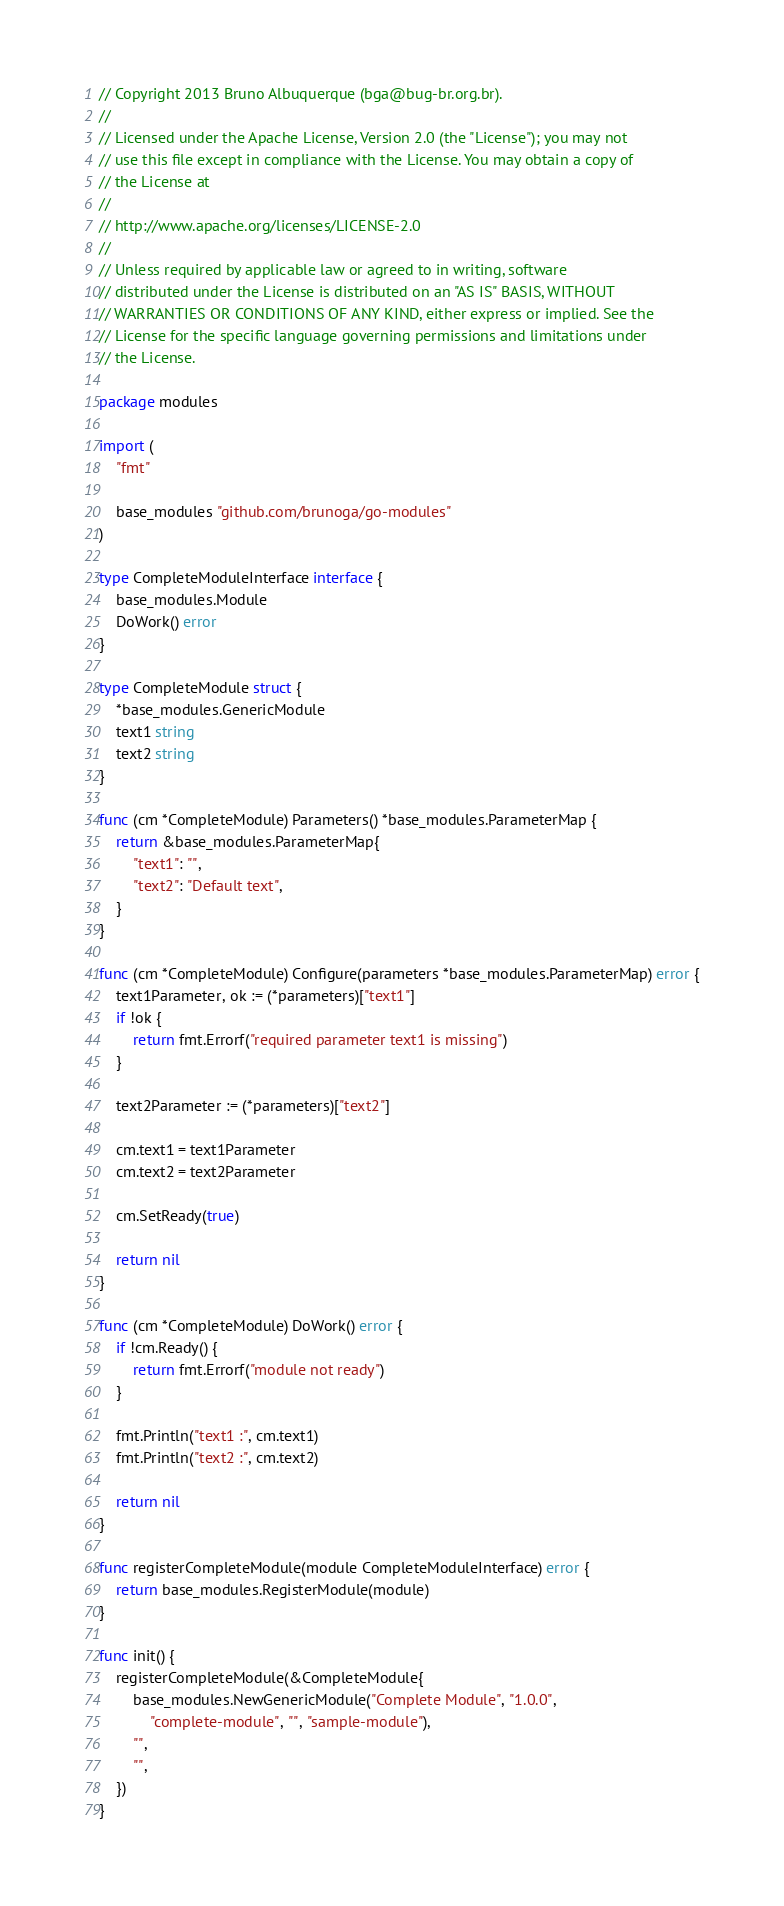<code> <loc_0><loc_0><loc_500><loc_500><_Go_>// Copyright 2013 Bruno Albuquerque (bga@bug-br.org.br).
//
// Licensed under the Apache License, Version 2.0 (the "License"); you may not
// use this file except in compliance with the License. You may obtain a copy of
// the License at
//
// http://www.apache.org/licenses/LICENSE-2.0
//
// Unless required by applicable law or agreed to in writing, software
// distributed under the License is distributed on an "AS IS" BASIS, WITHOUT
// WARRANTIES OR CONDITIONS OF ANY KIND, either express or implied. See the
// License for the specific language governing permissions and limitations under
// the License.

package modules

import (
	"fmt"

	base_modules "github.com/brunoga/go-modules"
)

type CompleteModuleInterface interface {
	base_modules.Module
	DoWork() error
}

type CompleteModule struct {
	*base_modules.GenericModule
	text1 string
	text2 string
}

func (cm *CompleteModule) Parameters() *base_modules.ParameterMap {
	return &base_modules.ParameterMap{
		"text1": "",
		"text2": "Default text",
	}
}

func (cm *CompleteModule) Configure(parameters *base_modules.ParameterMap) error {
	text1Parameter, ok := (*parameters)["text1"]
	if !ok {
		return fmt.Errorf("required parameter text1 is missing")
	}

	text2Parameter := (*parameters)["text2"]

	cm.text1 = text1Parameter
	cm.text2 = text2Parameter

	cm.SetReady(true)

	return nil
}

func (cm *CompleteModule) DoWork() error {
	if !cm.Ready() {
		return fmt.Errorf("module not ready")
	}

	fmt.Println("text1 :", cm.text1)
	fmt.Println("text2 :", cm.text2)

	return nil
}

func registerCompleteModule(module CompleteModuleInterface) error {
	return base_modules.RegisterModule(module)
}

func init() {
	registerCompleteModule(&CompleteModule{
		base_modules.NewGenericModule("Complete Module", "1.0.0",
			"complete-module", "", "sample-module"),
		"",
		"",
	})
}
</code> 